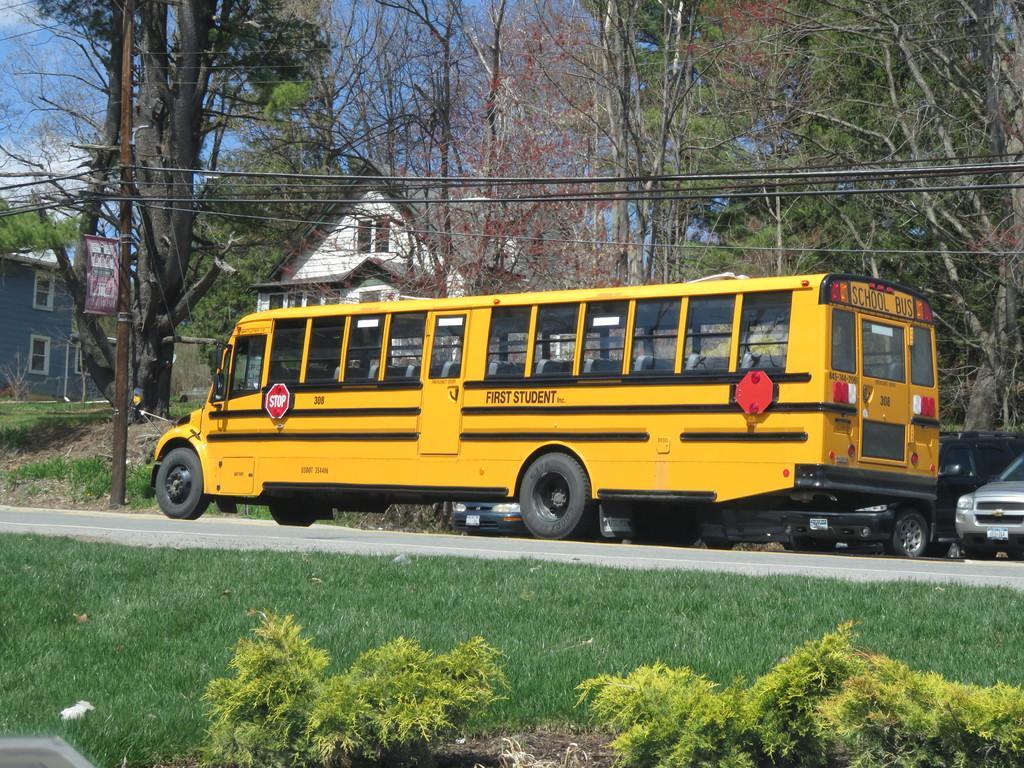How would you summarize this image in a sentence or two? In this image we can see many vehicles. Also there is a road. On the ground there is grass. And there are plants. In the back there are trees and buildings with windows. Also there is sky. 